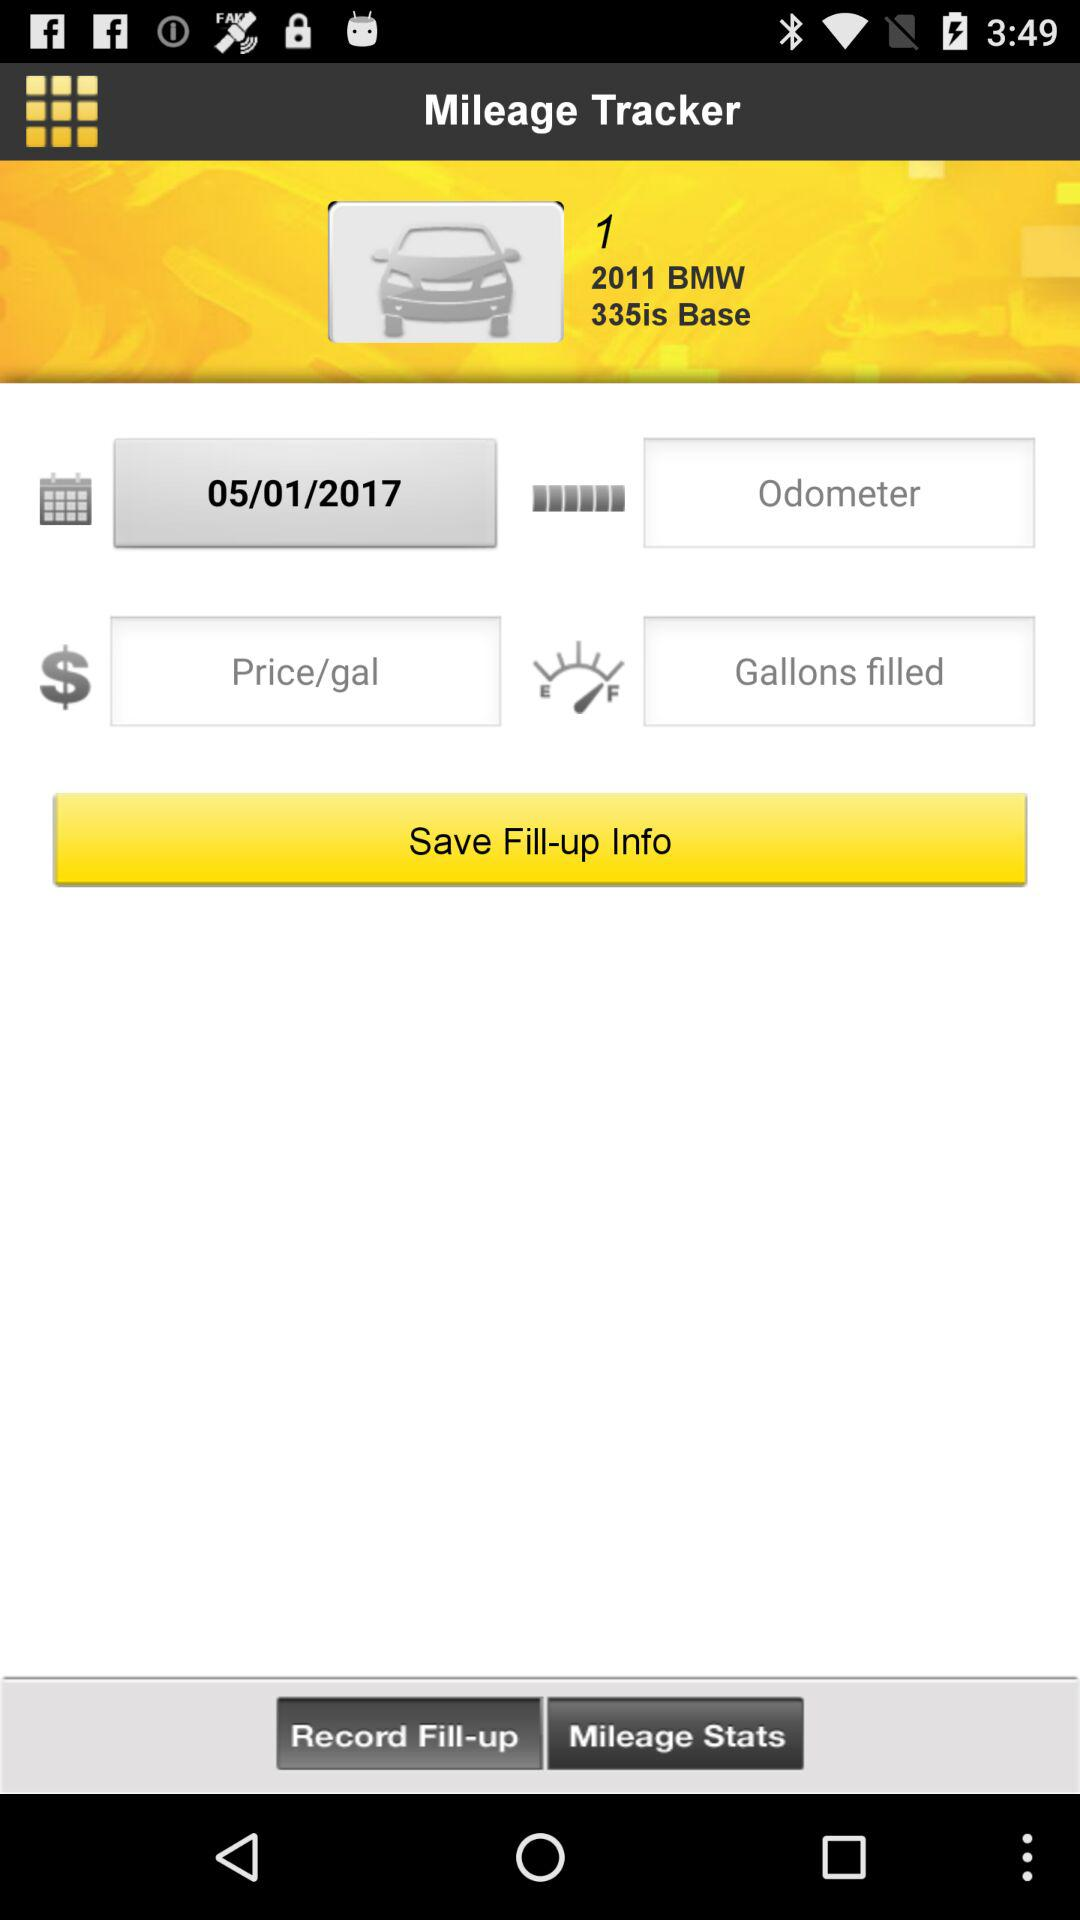Which is the base model? The base model is the "2011 BMW 335is". 